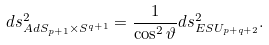<formula> <loc_0><loc_0><loc_500><loc_500>d s _ { A d S _ { p + 1 } \times S ^ { q + 1 } } ^ { 2 } = \frac { 1 } { \cos ^ { 2 } { \vartheta } } d s _ { E S U _ { p + q + 2 } } ^ { 2 } .</formula> 